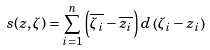<formula> <loc_0><loc_0><loc_500><loc_500>s ( z , \zeta ) = \sum _ { i = 1 } ^ { n } \left ( \overline { \zeta _ { i } } - \overline { z _ { i } } \right ) d \left ( \zeta _ { i } - z _ { i } \right )</formula> 